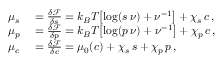<formula> <loc_0><loc_0><loc_500><loc_500>\begin{array} { r l } { \mu _ { s } } & = \frac { \delta \mathcal { F } } { \delta s } = k _ { B } T \left [ \log ( s \, \nu ) + \nu ^ { - 1 } \right ] + \chi _ { s } \, c \, , } \\ { \mu _ { p } } & = \frac { \delta \mathcal { F } } { \delta p } = k _ { B } T \left [ \log ( p \, \nu ) + \nu ^ { - 1 } \right ] + \chi _ { p } \, c \, , } \\ { \mu _ { c } } & = \frac { \delta \mathcal { F } } { \delta c } = \mu _ { 0 } ( c ) + \chi _ { s } \, s + \chi _ { p } \, p \, , } \end{array}</formula> 